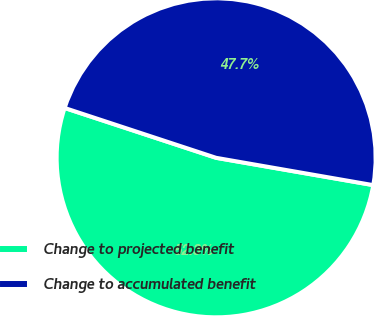<chart> <loc_0><loc_0><loc_500><loc_500><pie_chart><fcel>Change to projected benefit<fcel>Change to accumulated benefit<nl><fcel>52.32%<fcel>47.68%<nl></chart> 